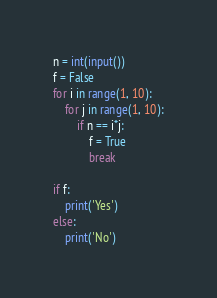<code> <loc_0><loc_0><loc_500><loc_500><_Python_>n = int(input())
f = False
for i in range(1, 10):
    for j in range(1, 10):
        if n == i*j:
            f = True
            break

if f:
    print('Yes')
else:
    print('No')</code> 